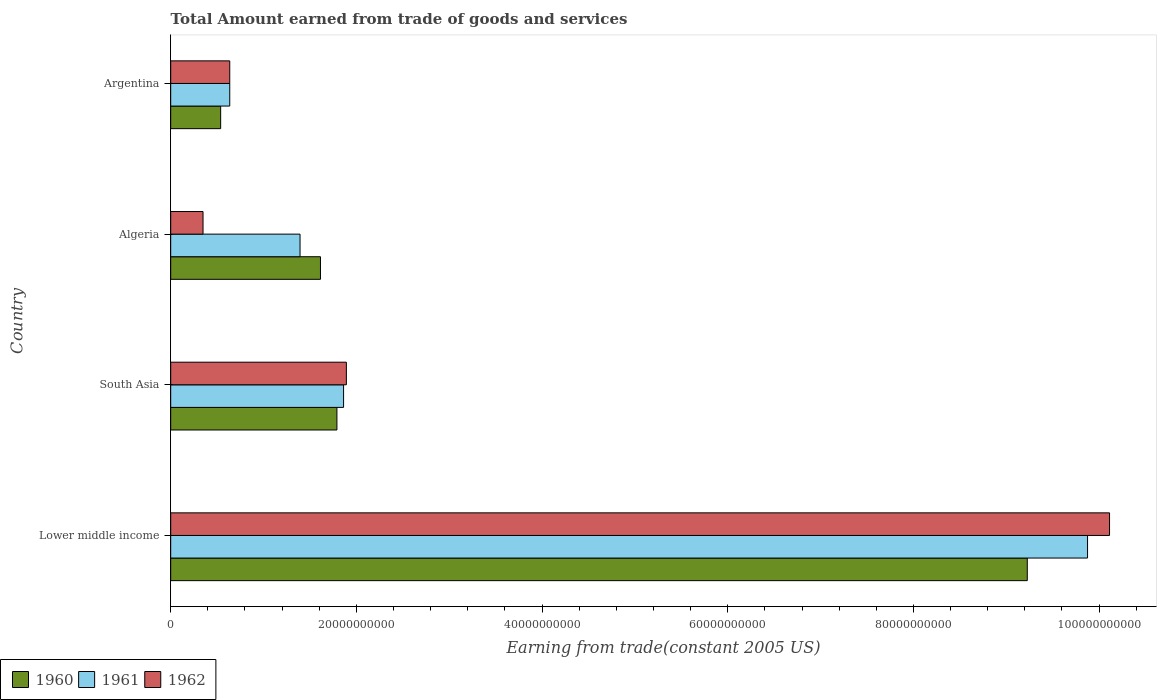What is the label of the 4th group of bars from the top?
Make the answer very short. Lower middle income. What is the total amount earned by trading goods and services in 1960 in Lower middle income?
Make the answer very short. 9.23e+1. Across all countries, what is the maximum total amount earned by trading goods and services in 1961?
Your answer should be compact. 9.88e+1. Across all countries, what is the minimum total amount earned by trading goods and services in 1960?
Your answer should be compact. 5.38e+09. In which country was the total amount earned by trading goods and services in 1960 maximum?
Give a very brief answer. Lower middle income. What is the total total amount earned by trading goods and services in 1960 in the graph?
Your response must be concise. 1.32e+11. What is the difference between the total amount earned by trading goods and services in 1961 in Algeria and that in Lower middle income?
Your answer should be very brief. -8.48e+1. What is the difference between the total amount earned by trading goods and services in 1962 in Argentina and the total amount earned by trading goods and services in 1961 in Algeria?
Ensure brevity in your answer.  -7.57e+09. What is the average total amount earned by trading goods and services in 1962 per country?
Your answer should be compact. 3.25e+1. What is the difference between the total amount earned by trading goods and services in 1962 and total amount earned by trading goods and services in 1960 in South Asia?
Give a very brief answer. 1.02e+09. In how many countries, is the total amount earned by trading goods and services in 1961 greater than 88000000000 US$?
Offer a terse response. 1. What is the ratio of the total amount earned by trading goods and services in 1961 in Algeria to that in South Asia?
Give a very brief answer. 0.75. Is the difference between the total amount earned by trading goods and services in 1962 in Algeria and Argentina greater than the difference between the total amount earned by trading goods and services in 1960 in Algeria and Argentina?
Offer a terse response. No. What is the difference between the highest and the second highest total amount earned by trading goods and services in 1961?
Make the answer very short. 8.01e+1. What is the difference between the highest and the lowest total amount earned by trading goods and services in 1960?
Offer a terse response. 8.69e+1. In how many countries, is the total amount earned by trading goods and services in 1962 greater than the average total amount earned by trading goods and services in 1962 taken over all countries?
Your response must be concise. 1. Is it the case that in every country, the sum of the total amount earned by trading goods and services in 1961 and total amount earned by trading goods and services in 1962 is greater than the total amount earned by trading goods and services in 1960?
Keep it short and to the point. Yes. How many bars are there?
Your answer should be compact. 12. How many countries are there in the graph?
Make the answer very short. 4. What is the difference between two consecutive major ticks on the X-axis?
Provide a short and direct response. 2.00e+1. Are the values on the major ticks of X-axis written in scientific E-notation?
Offer a very short reply. No. Does the graph contain grids?
Your answer should be very brief. No. How many legend labels are there?
Offer a terse response. 3. How are the legend labels stacked?
Your answer should be compact. Horizontal. What is the title of the graph?
Provide a short and direct response. Total Amount earned from trade of goods and services. What is the label or title of the X-axis?
Ensure brevity in your answer.  Earning from trade(constant 2005 US). What is the Earning from trade(constant 2005 US) of 1960 in Lower middle income?
Provide a succinct answer. 9.23e+1. What is the Earning from trade(constant 2005 US) of 1961 in Lower middle income?
Provide a short and direct response. 9.88e+1. What is the Earning from trade(constant 2005 US) of 1962 in Lower middle income?
Your answer should be very brief. 1.01e+11. What is the Earning from trade(constant 2005 US) of 1960 in South Asia?
Provide a short and direct response. 1.79e+1. What is the Earning from trade(constant 2005 US) of 1961 in South Asia?
Give a very brief answer. 1.86e+1. What is the Earning from trade(constant 2005 US) of 1962 in South Asia?
Provide a succinct answer. 1.89e+1. What is the Earning from trade(constant 2005 US) of 1960 in Algeria?
Your response must be concise. 1.61e+1. What is the Earning from trade(constant 2005 US) in 1961 in Algeria?
Your answer should be compact. 1.39e+1. What is the Earning from trade(constant 2005 US) of 1962 in Algeria?
Offer a terse response. 3.48e+09. What is the Earning from trade(constant 2005 US) in 1960 in Argentina?
Provide a succinct answer. 5.38e+09. What is the Earning from trade(constant 2005 US) of 1961 in Argentina?
Ensure brevity in your answer.  6.36e+09. What is the Earning from trade(constant 2005 US) of 1962 in Argentina?
Provide a short and direct response. 6.36e+09. Across all countries, what is the maximum Earning from trade(constant 2005 US) in 1960?
Your answer should be very brief. 9.23e+1. Across all countries, what is the maximum Earning from trade(constant 2005 US) in 1961?
Keep it short and to the point. 9.88e+1. Across all countries, what is the maximum Earning from trade(constant 2005 US) in 1962?
Your response must be concise. 1.01e+11. Across all countries, what is the minimum Earning from trade(constant 2005 US) in 1960?
Your response must be concise. 5.38e+09. Across all countries, what is the minimum Earning from trade(constant 2005 US) in 1961?
Offer a terse response. 6.36e+09. Across all countries, what is the minimum Earning from trade(constant 2005 US) in 1962?
Ensure brevity in your answer.  3.48e+09. What is the total Earning from trade(constant 2005 US) of 1960 in the graph?
Ensure brevity in your answer.  1.32e+11. What is the total Earning from trade(constant 2005 US) in 1961 in the graph?
Offer a very short reply. 1.38e+11. What is the total Earning from trade(constant 2005 US) of 1962 in the graph?
Provide a succinct answer. 1.30e+11. What is the difference between the Earning from trade(constant 2005 US) of 1960 in Lower middle income and that in South Asia?
Keep it short and to the point. 7.44e+1. What is the difference between the Earning from trade(constant 2005 US) of 1961 in Lower middle income and that in South Asia?
Your answer should be very brief. 8.01e+1. What is the difference between the Earning from trade(constant 2005 US) in 1962 in Lower middle income and that in South Asia?
Offer a terse response. 8.22e+1. What is the difference between the Earning from trade(constant 2005 US) in 1960 in Lower middle income and that in Algeria?
Provide a succinct answer. 7.61e+1. What is the difference between the Earning from trade(constant 2005 US) of 1961 in Lower middle income and that in Algeria?
Offer a terse response. 8.48e+1. What is the difference between the Earning from trade(constant 2005 US) in 1962 in Lower middle income and that in Algeria?
Your answer should be compact. 9.76e+1. What is the difference between the Earning from trade(constant 2005 US) in 1960 in Lower middle income and that in Argentina?
Provide a succinct answer. 8.69e+1. What is the difference between the Earning from trade(constant 2005 US) in 1961 in Lower middle income and that in Argentina?
Keep it short and to the point. 9.24e+1. What is the difference between the Earning from trade(constant 2005 US) in 1962 in Lower middle income and that in Argentina?
Your answer should be compact. 9.48e+1. What is the difference between the Earning from trade(constant 2005 US) in 1960 in South Asia and that in Algeria?
Give a very brief answer. 1.77e+09. What is the difference between the Earning from trade(constant 2005 US) in 1961 in South Asia and that in Algeria?
Your response must be concise. 4.69e+09. What is the difference between the Earning from trade(constant 2005 US) of 1962 in South Asia and that in Algeria?
Offer a very short reply. 1.54e+1. What is the difference between the Earning from trade(constant 2005 US) of 1960 in South Asia and that in Argentina?
Keep it short and to the point. 1.25e+1. What is the difference between the Earning from trade(constant 2005 US) of 1961 in South Asia and that in Argentina?
Ensure brevity in your answer.  1.23e+1. What is the difference between the Earning from trade(constant 2005 US) in 1962 in South Asia and that in Argentina?
Provide a succinct answer. 1.26e+1. What is the difference between the Earning from trade(constant 2005 US) in 1960 in Algeria and that in Argentina?
Your answer should be very brief. 1.08e+1. What is the difference between the Earning from trade(constant 2005 US) in 1961 in Algeria and that in Argentina?
Your answer should be very brief. 7.57e+09. What is the difference between the Earning from trade(constant 2005 US) of 1962 in Algeria and that in Argentina?
Give a very brief answer. -2.88e+09. What is the difference between the Earning from trade(constant 2005 US) of 1960 in Lower middle income and the Earning from trade(constant 2005 US) of 1961 in South Asia?
Keep it short and to the point. 7.36e+1. What is the difference between the Earning from trade(constant 2005 US) of 1960 in Lower middle income and the Earning from trade(constant 2005 US) of 1962 in South Asia?
Provide a succinct answer. 7.33e+1. What is the difference between the Earning from trade(constant 2005 US) in 1961 in Lower middle income and the Earning from trade(constant 2005 US) in 1962 in South Asia?
Your response must be concise. 7.98e+1. What is the difference between the Earning from trade(constant 2005 US) in 1960 in Lower middle income and the Earning from trade(constant 2005 US) in 1961 in Algeria?
Your answer should be compact. 7.83e+1. What is the difference between the Earning from trade(constant 2005 US) in 1960 in Lower middle income and the Earning from trade(constant 2005 US) in 1962 in Algeria?
Keep it short and to the point. 8.88e+1. What is the difference between the Earning from trade(constant 2005 US) of 1961 in Lower middle income and the Earning from trade(constant 2005 US) of 1962 in Algeria?
Your answer should be very brief. 9.53e+1. What is the difference between the Earning from trade(constant 2005 US) of 1960 in Lower middle income and the Earning from trade(constant 2005 US) of 1961 in Argentina?
Your answer should be compact. 8.59e+1. What is the difference between the Earning from trade(constant 2005 US) in 1960 in Lower middle income and the Earning from trade(constant 2005 US) in 1962 in Argentina?
Offer a very short reply. 8.59e+1. What is the difference between the Earning from trade(constant 2005 US) in 1961 in Lower middle income and the Earning from trade(constant 2005 US) in 1962 in Argentina?
Your response must be concise. 9.24e+1. What is the difference between the Earning from trade(constant 2005 US) of 1960 in South Asia and the Earning from trade(constant 2005 US) of 1961 in Algeria?
Ensure brevity in your answer.  3.97e+09. What is the difference between the Earning from trade(constant 2005 US) in 1960 in South Asia and the Earning from trade(constant 2005 US) in 1962 in Algeria?
Your answer should be compact. 1.44e+1. What is the difference between the Earning from trade(constant 2005 US) in 1961 in South Asia and the Earning from trade(constant 2005 US) in 1962 in Algeria?
Offer a very short reply. 1.51e+1. What is the difference between the Earning from trade(constant 2005 US) of 1960 in South Asia and the Earning from trade(constant 2005 US) of 1961 in Argentina?
Your answer should be compact. 1.15e+1. What is the difference between the Earning from trade(constant 2005 US) of 1960 in South Asia and the Earning from trade(constant 2005 US) of 1962 in Argentina?
Make the answer very short. 1.15e+1. What is the difference between the Earning from trade(constant 2005 US) in 1961 in South Asia and the Earning from trade(constant 2005 US) in 1962 in Argentina?
Offer a very short reply. 1.23e+1. What is the difference between the Earning from trade(constant 2005 US) in 1960 in Algeria and the Earning from trade(constant 2005 US) in 1961 in Argentina?
Make the answer very short. 9.77e+09. What is the difference between the Earning from trade(constant 2005 US) in 1960 in Algeria and the Earning from trade(constant 2005 US) in 1962 in Argentina?
Your answer should be very brief. 9.77e+09. What is the difference between the Earning from trade(constant 2005 US) in 1961 in Algeria and the Earning from trade(constant 2005 US) in 1962 in Argentina?
Offer a terse response. 7.57e+09. What is the average Earning from trade(constant 2005 US) in 1960 per country?
Give a very brief answer. 3.29e+1. What is the average Earning from trade(constant 2005 US) of 1961 per country?
Your response must be concise. 3.44e+1. What is the average Earning from trade(constant 2005 US) in 1962 per country?
Ensure brevity in your answer.  3.25e+1. What is the difference between the Earning from trade(constant 2005 US) in 1960 and Earning from trade(constant 2005 US) in 1961 in Lower middle income?
Your answer should be compact. -6.49e+09. What is the difference between the Earning from trade(constant 2005 US) in 1960 and Earning from trade(constant 2005 US) in 1962 in Lower middle income?
Keep it short and to the point. -8.86e+09. What is the difference between the Earning from trade(constant 2005 US) of 1961 and Earning from trade(constant 2005 US) of 1962 in Lower middle income?
Make the answer very short. -2.37e+09. What is the difference between the Earning from trade(constant 2005 US) in 1960 and Earning from trade(constant 2005 US) in 1961 in South Asia?
Offer a terse response. -7.18e+08. What is the difference between the Earning from trade(constant 2005 US) of 1960 and Earning from trade(constant 2005 US) of 1962 in South Asia?
Offer a terse response. -1.02e+09. What is the difference between the Earning from trade(constant 2005 US) in 1961 and Earning from trade(constant 2005 US) in 1962 in South Asia?
Keep it short and to the point. -3.00e+08. What is the difference between the Earning from trade(constant 2005 US) of 1960 and Earning from trade(constant 2005 US) of 1961 in Algeria?
Your answer should be very brief. 2.20e+09. What is the difference between the Earning from trade(constant 2005 US) in 1960 and Earning from trade(constant 2005 US) in 1962 in Algeria?
Your response must be concise. 1.26e+1. What is the difference between the Earning from trade(constant 2005 US) in 1961 and Earning from trade(constant 2005 US) in 1962 in Algeria?
Give a very brief answer. 1.04e+1. What is the difference between the Earning from trade(constant 2005 US) of 1960 and Earning from trade(constant 2005 US) of 1961 in Argentina?
Offer a very short reply. -9.78e+08. What is the difference between the Earning from trade(constant 2005 US) of 1960 and Earning from trade(constant 2005 US) of 1962 in Argentina?
Keep it short and to the point. -9.78e+08. What is the difference between the Earning from trade(constant 2005 US) of 1961 and Earning from trade(constant 2005 US) of 1962 in Argentina?
Provide a short and direct response. 0. What is the ratio of the Earning from trade(constant 2005 US) of 1960 in Lower middle income to that in South Asia?
Your answer should be very brief. 5.15. What is the ratio of the Earning from trade(constant 2005 US) of 1961 in Lower middle income to that in South Asia?
Ensure brevity in your answer.  5.3. What is the ratio of the Earning from trade(constant 2005 US) in 1962 in Lower middle income to that in South Asia?
Make the answer very short. 5.34. What is the ratio of the Earning from trade(constant 2005 US) of 1960 in Lower middle income to that in Algeria?
Offer a very short reply. 5.72. What is the ratio of the Earning from trade(constant 2005 US) in 1961 in Lower middle income to that in Algeria?
Ensure brevity in your answer.  7.09. What is the ratio of the Earning from trade(constant 2005 US) of 1962 in Lower middle income to that in Algeria?
Your response must be concise. 29.03. What is the ratio of the Earning from trade(constant 2005 US) of 1960 in Lower middle income to that in Argentina?
Your answer should be very brief. 17.14. What is the ratio of the Earning from trade(constant 2005 US) of 1961 in Lower middle income to that in Argentina?
Ensure brevity in your answer.  15.53. What is the ratio of the Earning from trade(constant 2005 US) in 1962 in Lower middle income to that in Argentina?
Provide a succinct answer. 15.9. What is the ratio of the Earning from trade(constant 2005 US) in 1960 in South Asia to that in Algeria?
Keep it short and to the point. 1.11. What is the ratio of the Earning from trade(constant 2005 US) in 1961 in South Asia to that in Algeria?
Ensure brevity in your answer.  1.34. What is the ratio of the Earning from trade(constant 2005 US) of 1962 in South Asia to that in Algeria?
Your answer should be compact. 5.43. What is the ratio of the Earning from trade(constant 2005 US) of 1960 in South Asia to that in Argentina?
Your response must be concise. 3.33. What is the ratio of the Earning from trade(constant 2005 US) in 1961 in South Asia to that in Argentina?
Ensure brevity in your answer.  2.93. What is the ratio of the Earning from trade(constant 2005 US) in 1962 in South Asia to that in Argentina?
Provide a short and direct response. 2.98. What is the ratio of the Earning from trade(constant 2005 US) of 1960 in Algeria to that in Argentina?
Give a very brief answer. 3. What is the ratio of the Earning from trade(constant 2005 US) in 1961 in Algeria to that in Argentina?
Ensure brevity in your answer.  2.19. What is the ratio of the Earning from trade(constant 2005 US) in 1962 in Algeria to that in Argentina?
Provide a short and direct response. 0.55. What is the difference between the highest and the second highest Earning from trade(constant 2005 US) in 1960?
Ensure brevity in your answer.  7.44e+1. What is the difference between the highest and the second highest Earning from trade(constant 2005 US) of 1961?
Your answer should be very brief. 8.01e+1. What is the difference between the highest and the second highest Earning from trade(constant 2005 US) of 1962?
Your response must be concise. 8.22e+1. What is the difference between the highest and the lowest Earning from trade(constant 2005 US) of 1960?
Ensure brevity in your answer.  8.69e+1. What is the difference between the highest and the lowest Earning from trade(constant 2005 US) of 1961?
Make the answer very short. 9.24e+1. What is the difference between the highest and the lowest Earning from trade(constant 2005 US) of 1962?
Offer a terse response. 9.76e+1. 